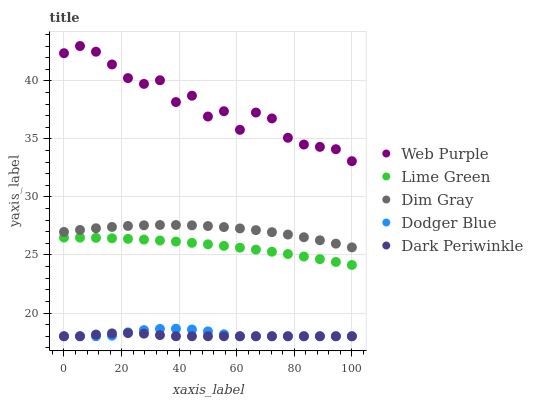Does Dark Periwinkle have the minimum area under the curve?
Answer yes or no. Yes. Does Web Purple have the maximum area under the curve?
Answer yes or no. Yes. Does Dim Gray have the minimum area under the curve?
Answer yes or no. No. Does Dim Gray have the maximum area under the curve?
Answer yes or no. No. Is Lime Green the smoothest?
Answer yes or no. Yes. Is Web Purple the roughest?
Answer yes or no. Yes. Is Dim Gray the smoothest?
Answer yes or no. No. Is Dim Gray the roughest?
Answer yes or no. No. Does Dodger Blue have the lowest value?
Answer yes or no. Yes. Does Dim Gray have the lowest value?
Answer yes or no. No. Does Web Purple have the highest value?
Answer yes or no. Yes. Does Dim Gray have the highest value?
Answer yes or no. No. Is Dim Gray less than Web Purple?
Answer yes or no. Yes. Is Web Purple greater than Lime Green?
Answer yes or no. Yes. Does Dodger Blue intersect Dark Periwinkle?
Answer yes or no. Yes. Is Dodger Blue less than Dark Periwinkle?
Answer yes or no. No. Is Dodger Blue greater than Dark Periwinkle?
Answer yes or no. No. Does Dim Gray intersect Web Purple?
Answer yes or no. No. 